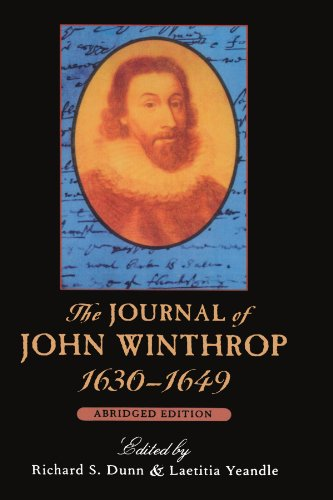Who is the author of this book? The author of the book depicted in the image is John Winthrop, a key figure in early American history. 